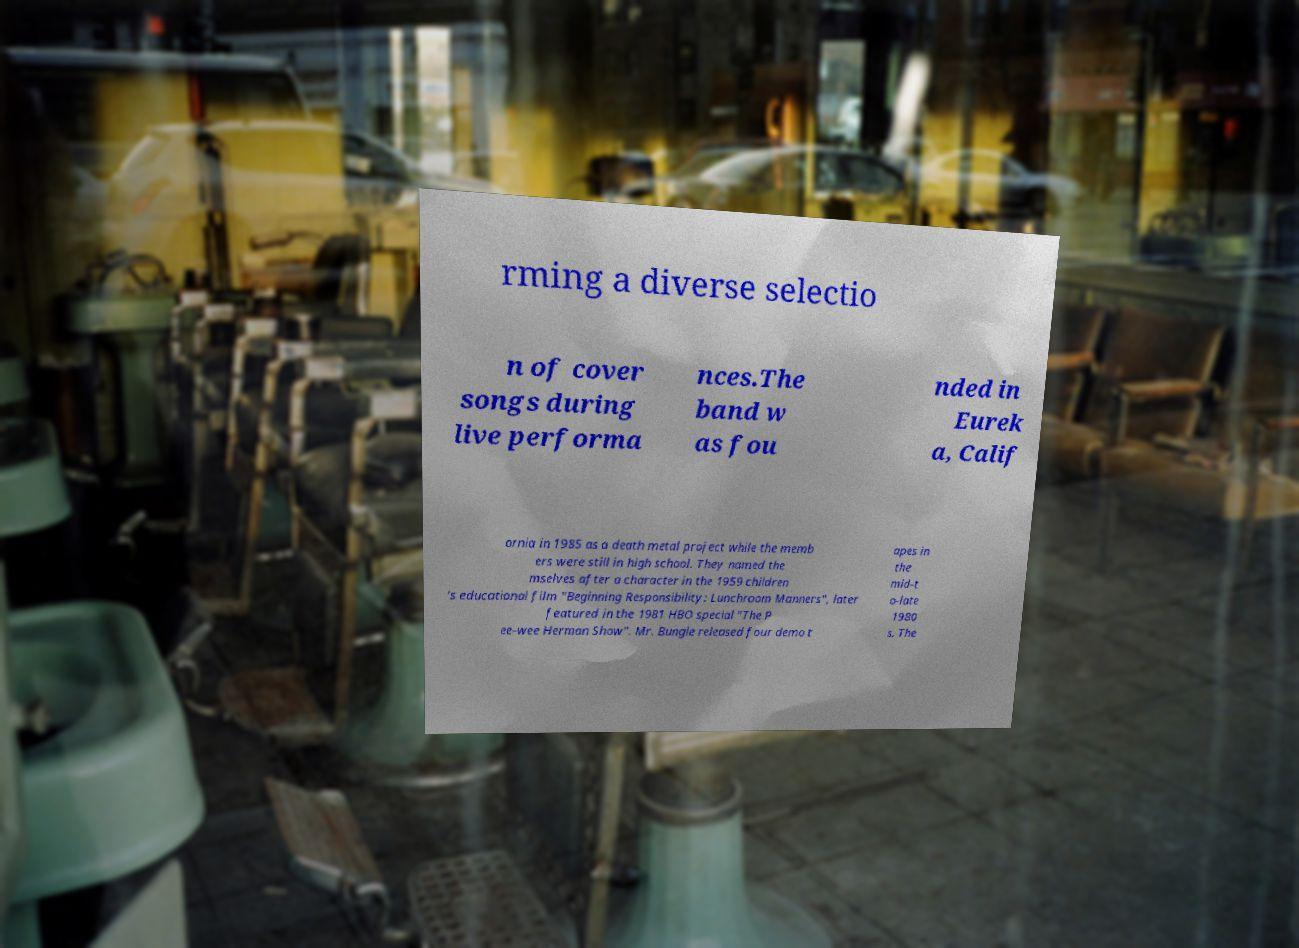There's text embedded in this image that I need extracted. Can you transcribe it verbatim? rming a diverse selectio n of cover songs during live performa nces.The band w as fou nded in Eurek a, Calif ornia in 1985 as a death metal project while the memb ers were still in high school. They named the mselves after a character in the 1959 children 's educational film "Beginning Responsibility: Lunchroom Manners", later featured in the 1981 HBO special "The P ee-wee Herman Show". Mr. Bungle released four demo t apes in the mid-t o-late 1980 s. The 